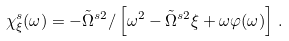<formula> <loc_0><loc_0><loc_500><loc_500>\chi _ { \xi } ^ { s } ( \omega ) = - \tilde { \Omega } ^ { s 2 } / \left [ \omega ^ { 2 } - \tilde { \Omega } ^ { s 2 } \xi + \omega \varphi ( \omega ) \right ] \, .</formula> 